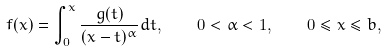Convert formula to latex. <formula><loc_0><loc_0><loc_500><loc_500>f ( x ) = \int _ { 0 } ^ { x } \frac { g ( t ) } { ( x - t ) ^ { \alpha } } d t , \quad 0 < \alpha < 1 , \quad 0 \leq x \leq b ,</formula> 